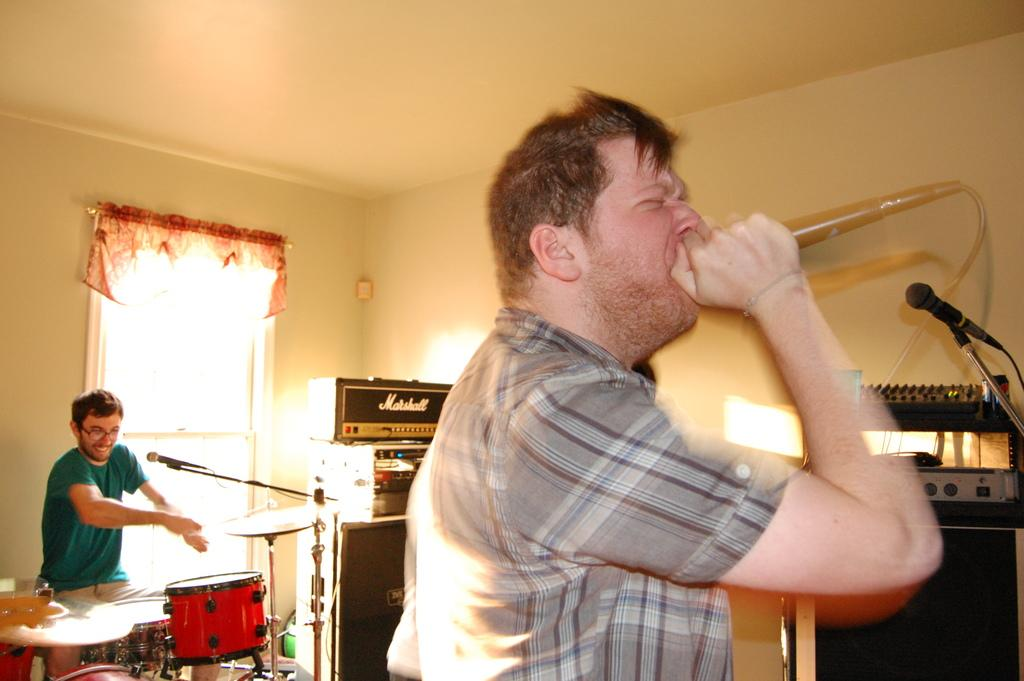How many people are in the room? There are 2 people in the room. What are the people doing in the room? The person at the front is holding a microphone and singing, while the person at the back is playing drums. Can you describe the window in the room? There is a window at the back of the room. What time is displayed on the clock in the room? There is no clock present in the image, so we cannot determine the time. 